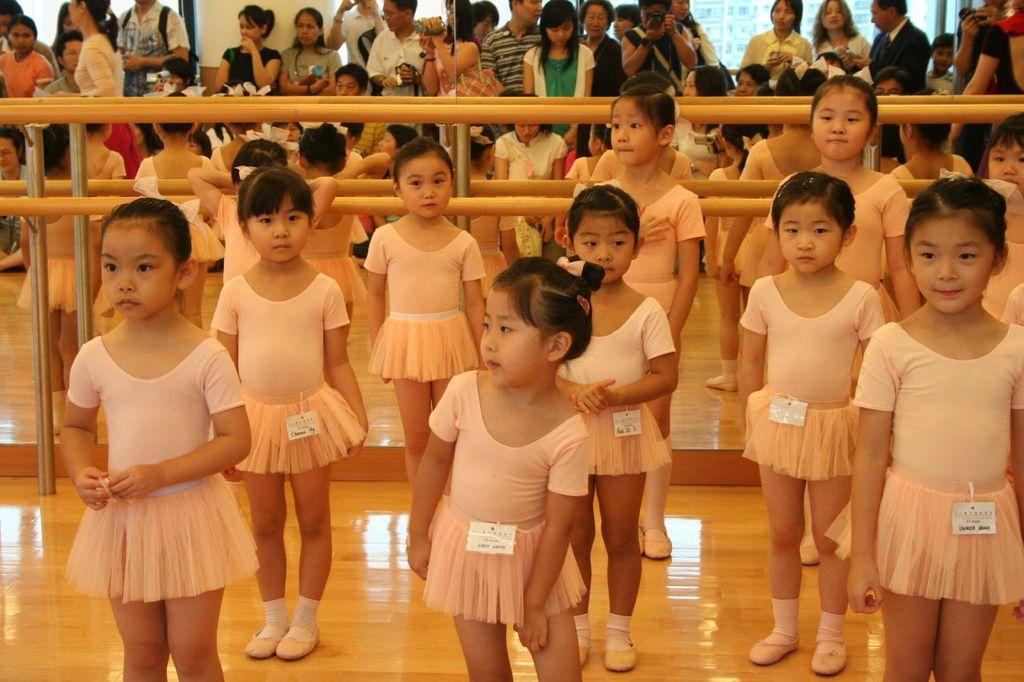How many kids are in the image? There are multiple kids in the image. What are the kids wearing? The kids are wearing the same costume. Where are the kids standing? The kids are standing on a stage. What can be seen behind the kids? There is a fence visible behind the kids. What is happening behind the fence? There are other people standing behind the fence. Can you see the moon in the image? No, the moon is not visible in the image. 